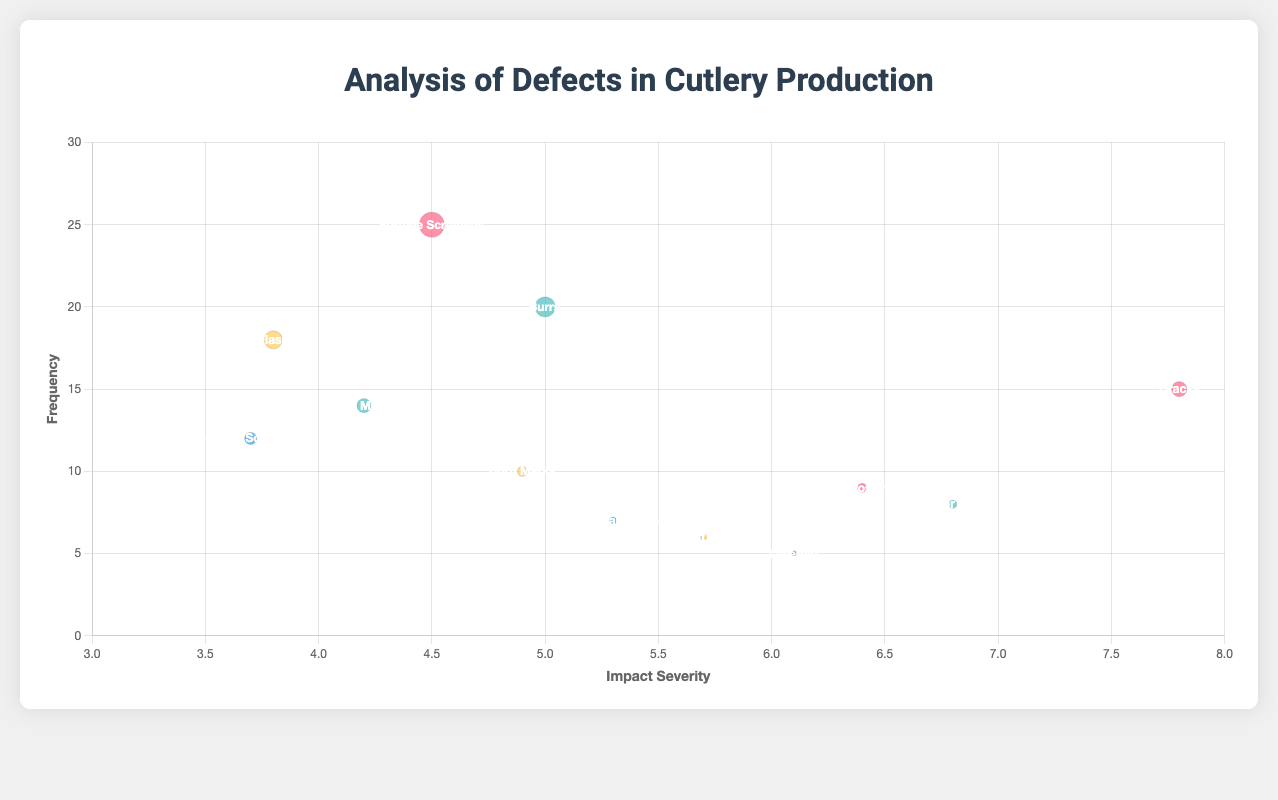What is the title of the chart? The title is displayed at the top of the chart and reads "Analysis of Defects in Cutlery Production".
Answer: Analysis of Defects in Cutlery Production What is the defect with the highest frequency in Forging? By looking at the bubble chart, the largest bubble under the Forging category is for Surface Scratches with a frequency of 25.
Answer: Surface Scratches Which manufacturing technique has the highest impact severity for a defect? The highest impact severity can be seen on the x-axis under the Forging technique for Cracks, with a severity of 7.8.
Answer: Forging for Cracks how many defects are associated with Injection Molding? Injection Molding is represented by three different defects: Burn Marks, Flash, and Short Shot.
Answer: 3 Do the defects related to Injection Molding generally have a higher or lower frequency compared to Cold Rolling? Comparing the bubble sizes (frequency) for Injection Molding (10, 18, 6) and Cold Rolling (12, 7, 5), Injection Molding has generally higher values.
Answer: Higher What is the average impact severity of defects related to Cold Rolling? Calculate by summing the impact severity for Cold Rolling defects and dividing by the total number of defects: (3.7 + 5.3 + 6.1)/3 = 5.03.
Answer: 5.03 Which defect type and manufacturing technique combination have a frequency of exactly 20? Look for the bubble with a frequency of 20; Burrs under Machining has a frequency of 20.
Answer: Burrs in Machining What is the difference in frequency between Chatter Marks in Machining and Surface Scratches in Forging? Subtract the frequency of Chatter Marks in Machining (8) from Surface Scratches in Forging (25): 25 - 8 = 17.
Answer: 17 Which defect type under Forging has the lowest impact severity, and what is its value? Under Forging, Surface Scratches has the lowest impact severity of 4.5.
Answer: Surface Scratches, 4.5 Based on the color, how many manufacturing techniques are represented in the chart? Each manufacturing technique has a distinct color. Four colors represent four manufacturing techniques: Forging, Cold Rolling, Injection Molding, and Machining.
Answer: 4 